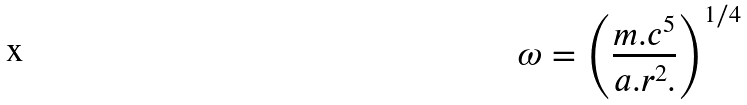Convert formula to latex. <formula><loc_0><loc_0><loc_500><loc_500>\omega = \left ( { { \frac { { m . c ^ { 5 } } } { { a . r ^ { 2 } . } } } } \right ) ^ { 1 / 4 }</formula> 